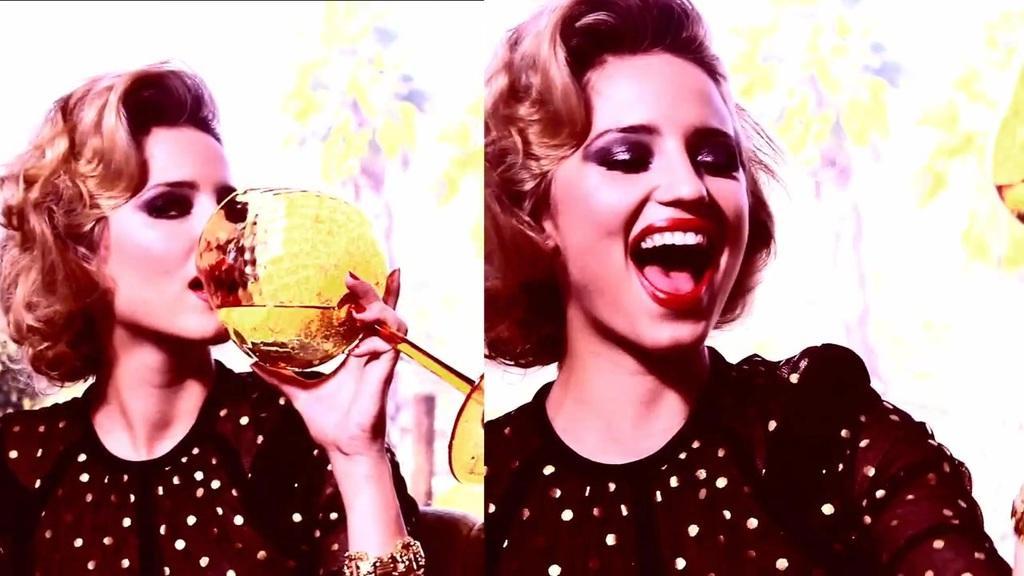Can you describe this image briefly? This is a collage image. There is a woman holding a glass to the left side of the image. To the right side of the image there is a woman. 